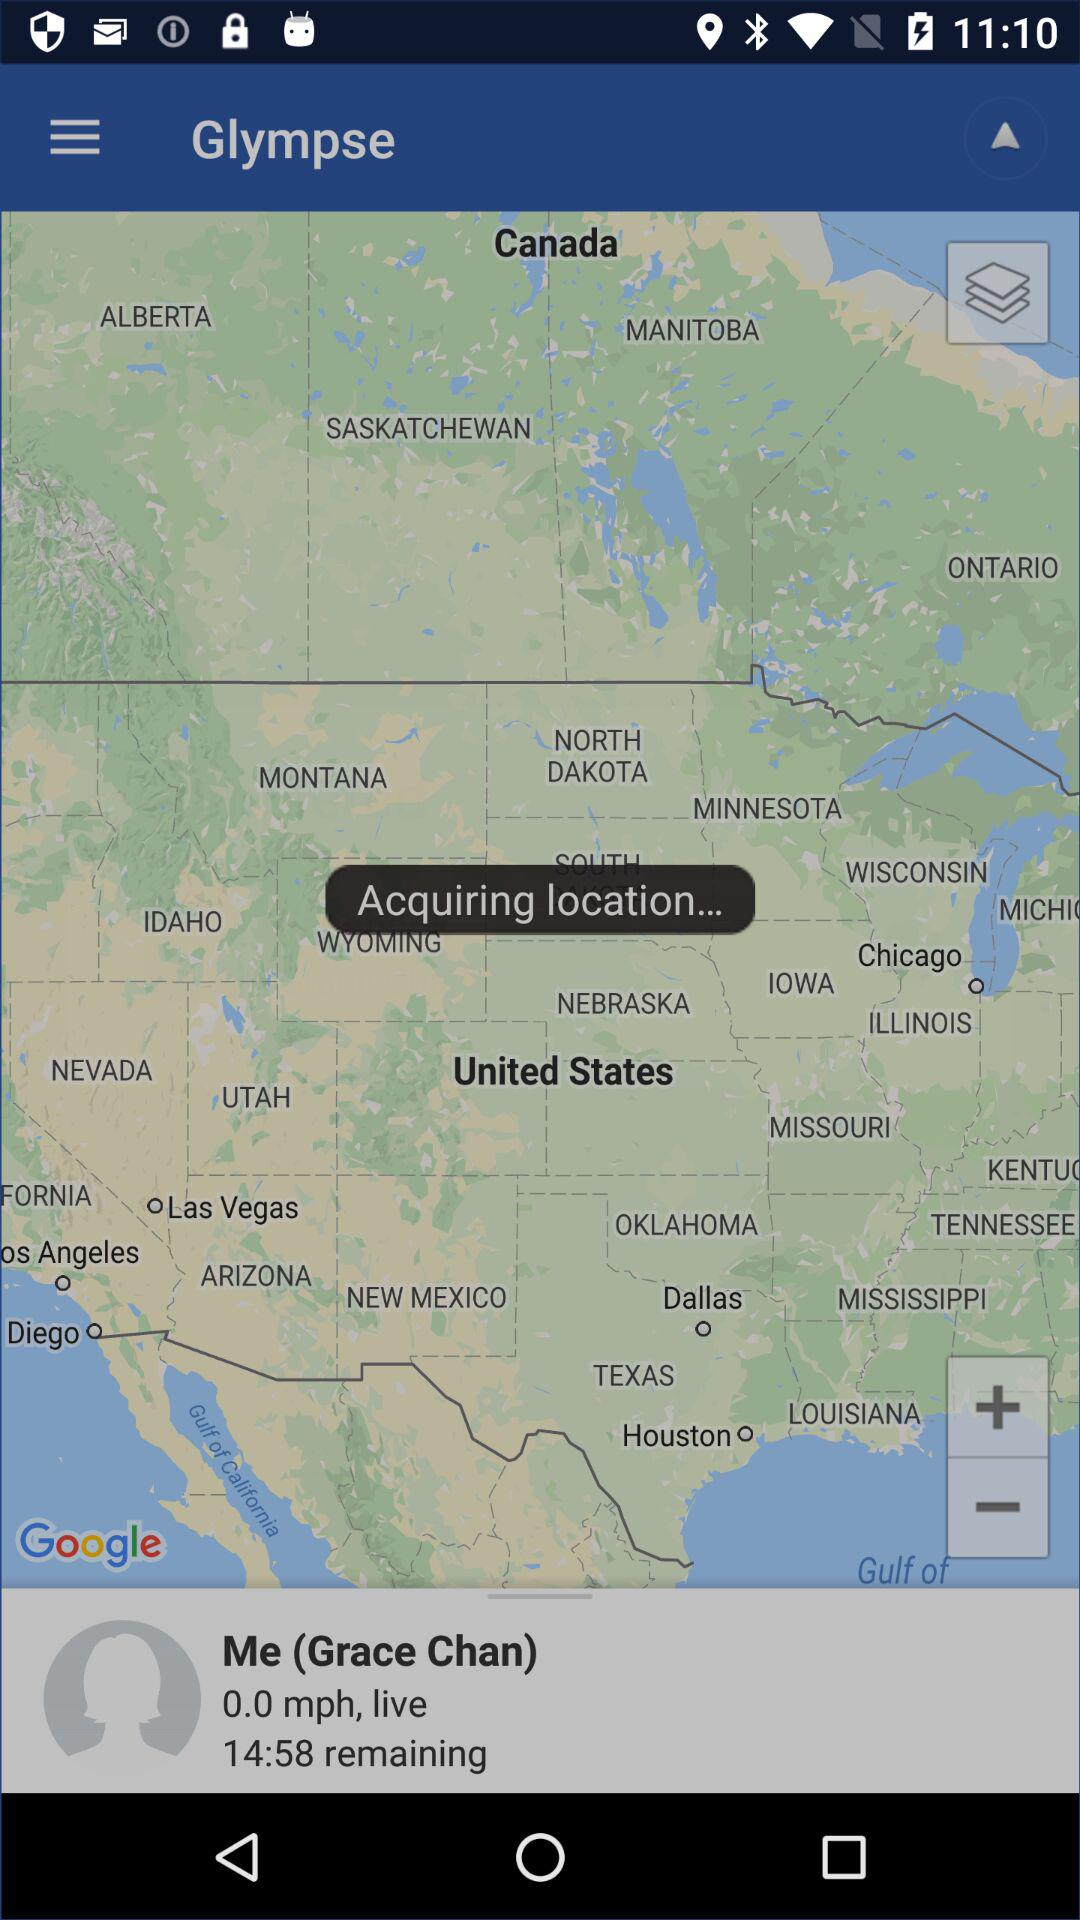How many items are in the user's history?
Answer the question using a single word or phrase. 0 